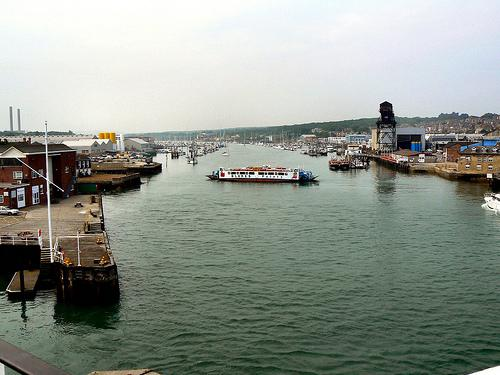Question: what are the two structures in the far left background?
Choices:
A. Stove pipes.
B. Industrial buildings.
C. Smokestacks.
D. Electric plant.
Answer with the letter. Answer: C Question: where was the picture taken?
Choices:
A. At the shore.
B. At a wharf.
C. The marina.
D. A fishing pier.
Answer with the letter. Answer: B Question: what color is the sky?
Choices:
A. Blue.
B. White.
C. Gray.
D. Orange.
Answer with the letter. Answer: C Question: what are the buildings built on?
Choices:
A. Pylons.
B. The wharf.
C. Docks.
D. The boardwalk.
Answer with the letter. Answer: C 